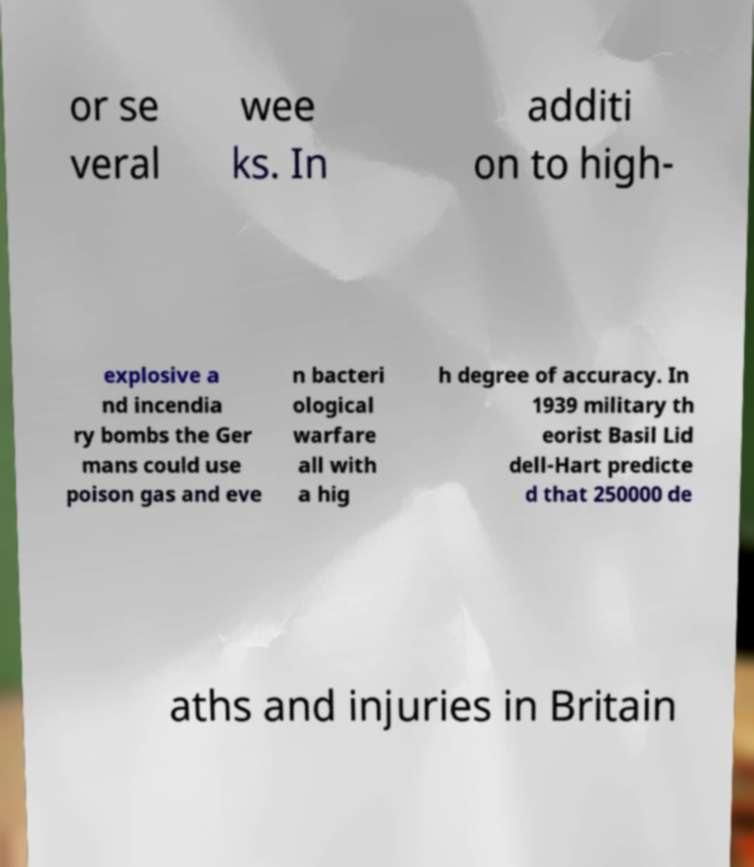For documentation purposes, I need the text within this image transcribed. Could you provide that? or se veral wee ks. In additi on to high- explosive a nd incendia ry bombs the Ger mans could use poison gas and eve n bacteri ological warfare all with a hig h degree of accuracy. In 1939 military th eorist Basil Lid dell-Hart predicte d that 250000 de aths and injuries in Britain 